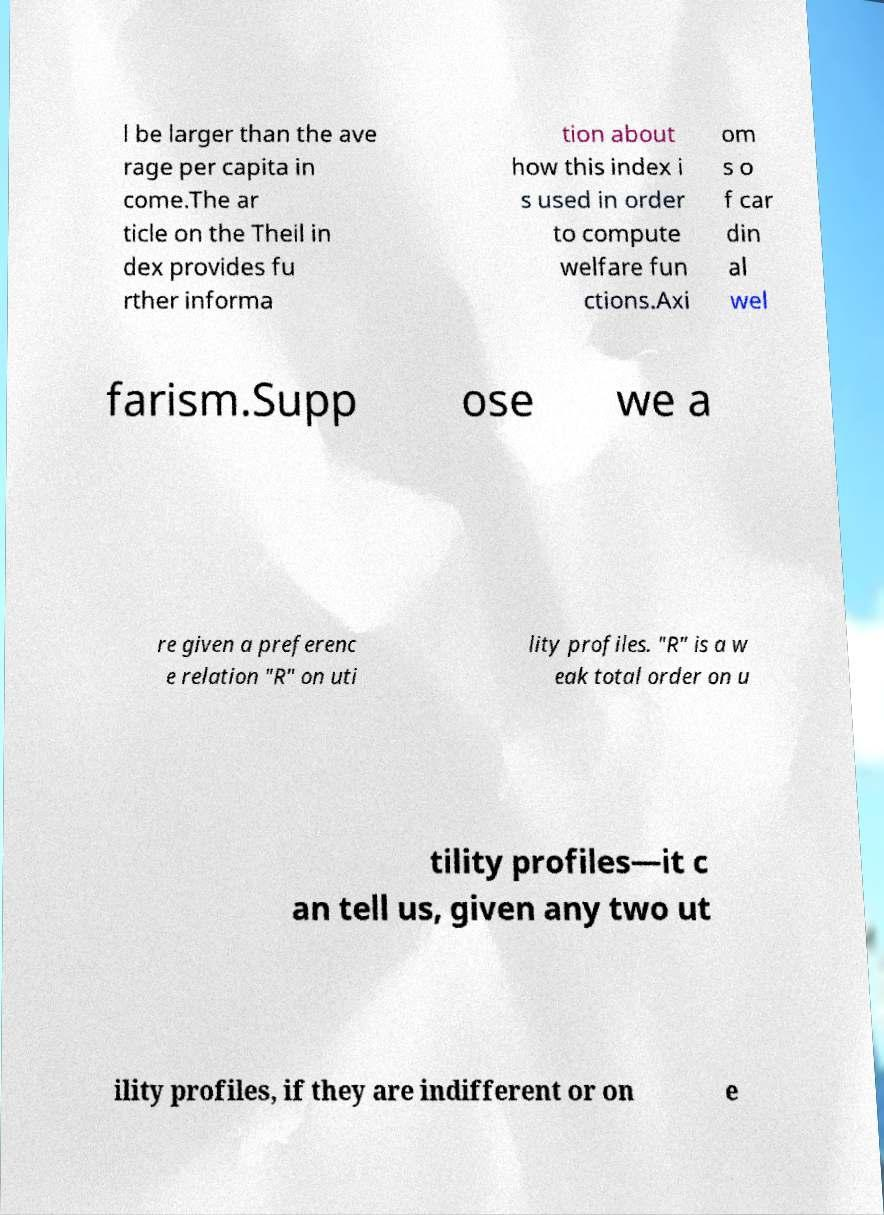Could you extract and type out the text from this image? l be larger than the ave rage per capita in come.The ar ticle on the Theil in dex provides fu rther informa tion about how this index i s used in order to compute welfare fun ctions.Axi om s o f car din al wel farism.Supp ose we a re given a preferenc e relation "R" on uti lity profiles. "R" is a w eak total order on u tility profiles—it c an tell us, given any two ut ility profiles, if they are indifferent or on e 